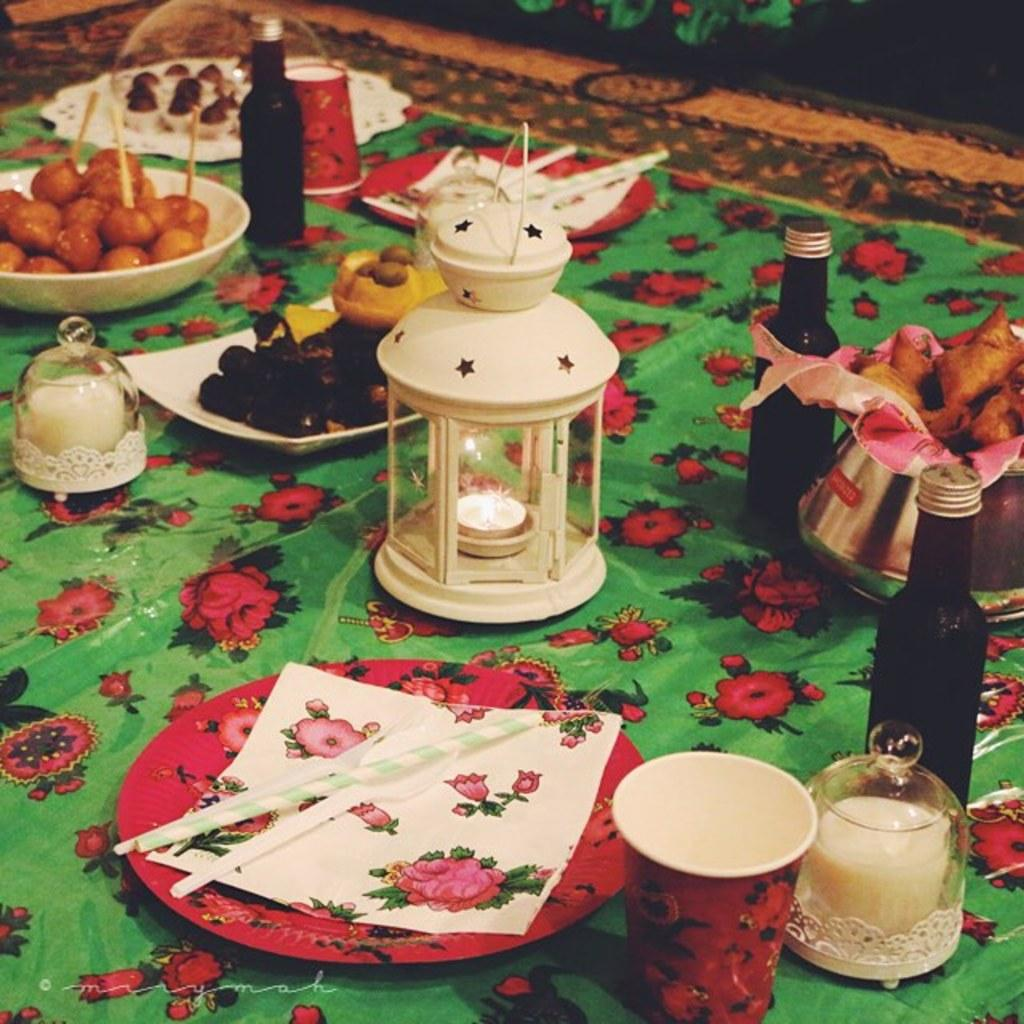What is the color of the surface in the image? The surface in the image is green. What types of objects can be seen on the surface? There are plates, cups, bottles, a bowl with a food item, and other objects on the surface. What might be used for holding liquids in the image? Cups and bottles on the surface can be used for holding liquids. What food item is in the bowl on the surface? The fact does not specify the type of food item in the bowl, only that there is a bowl with a food item in it. What type of plant is growing on the shelf in the image? There is no shelf or plant present in the image. What material is the wool made of in the image? There is no wool present in the image. 